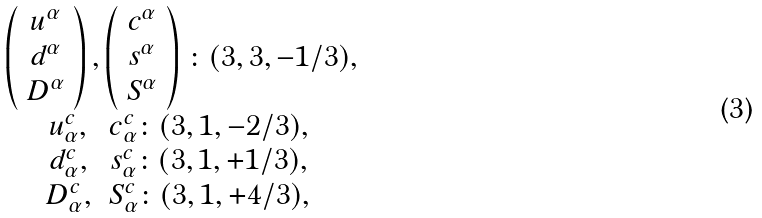<formula> <loc_0><loc_0><loc_500><loc_500>\begin{array} { c } { { \begin{array} { c c } { { \left ( \begin{array} { c } { { u ^ { \alpha } } } \\ { { d ^ { \alpha } } } \\ { { D ^ { \alpha } } } \end{array} \right ) , \left ( \begin{array} { c } { { c ^ { \alpha } } } \\ { { s ^ { \alpha } } } \\ { { S ^ { \alpha } } } \end{array} \right ) } } \end{array} \colon ( 3 , 3 , - 1 / 3 ) , } } \\ { { \begin{array} { c c } { { \begin{array} { c } { { u _ { \alpha } ^ { c } , } } \\ { { d _ { \alpha } ^ { c } , } } \\ { { D _ { \alpha } ^ { c } , } } \end{array} \begin{array} { c } { { c _ { \alpha } ^ { c } \colon ( 3 , 1 , - 2 / 3 ) , } } \\ { { s _ { \alpha } ^ { c } \colon ( 3 , 1 , + 1 / 3 ) , } } \\ { { S _ { \alpha } ^ { c } \colon ( 3 , 1 , + 4 / 3 ) , } } \end{array} } } \end{array} } } \end{array}</formula> 